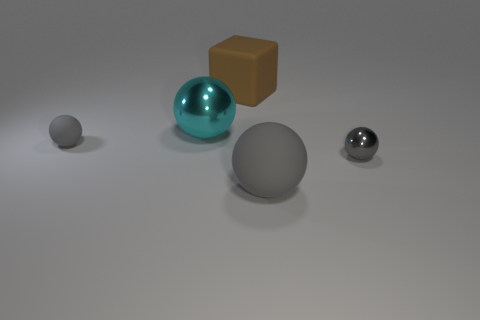Subtract all gray balls. How many balls are left? 1 Add 2 green metallic objects. How many objects exist? 7 Subtract all cyan spheres. How many spheres are left? 3 Subtract all spheres. How many objects are left? 1 Subtract 1 blocks. How many blocks are left? 0 Subtract all red spheres. Subtract all gray cubes. How many spheres are left? 4 Subtract all green cubes. How many red spheres are left? 0 Subtract all tiny shiny objects. Subtract all metallic spheres. How many objects are left? 2 Add 2 gray matte spheres. How many gray matte spheres are left? 4 Add 5 gray metal things. How many gray metal things exist? 6 